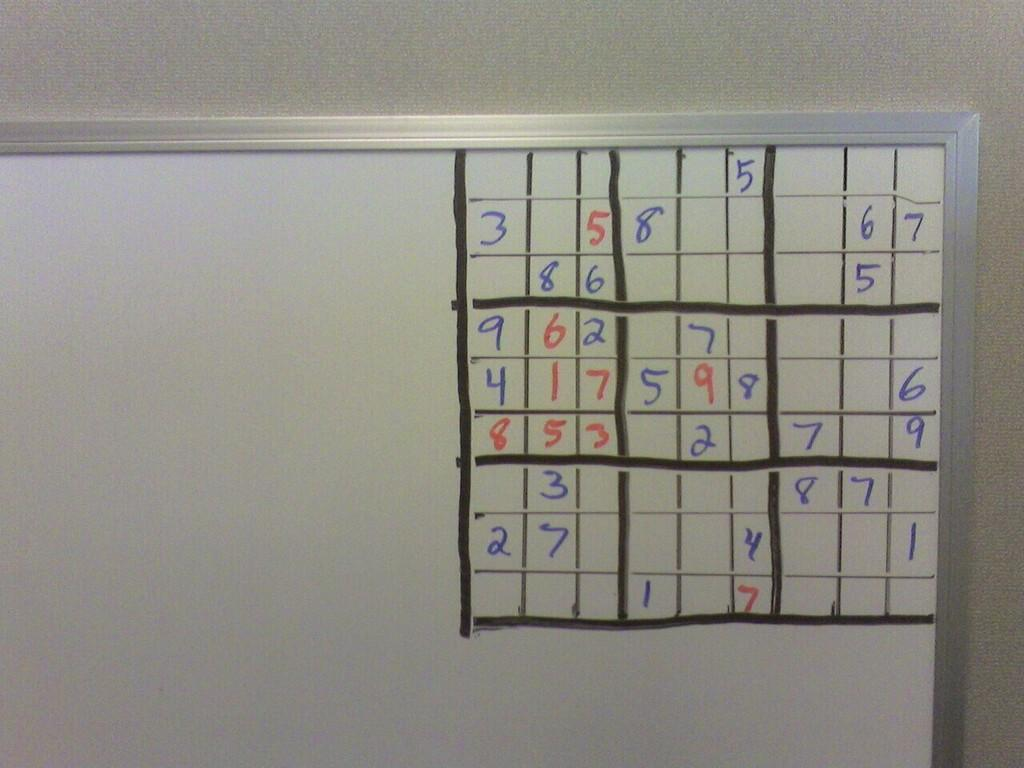<image>
Offer a succinct explanation of the picture presented. A game of Sudoku in progress. the bottom row says 1 and 7. 